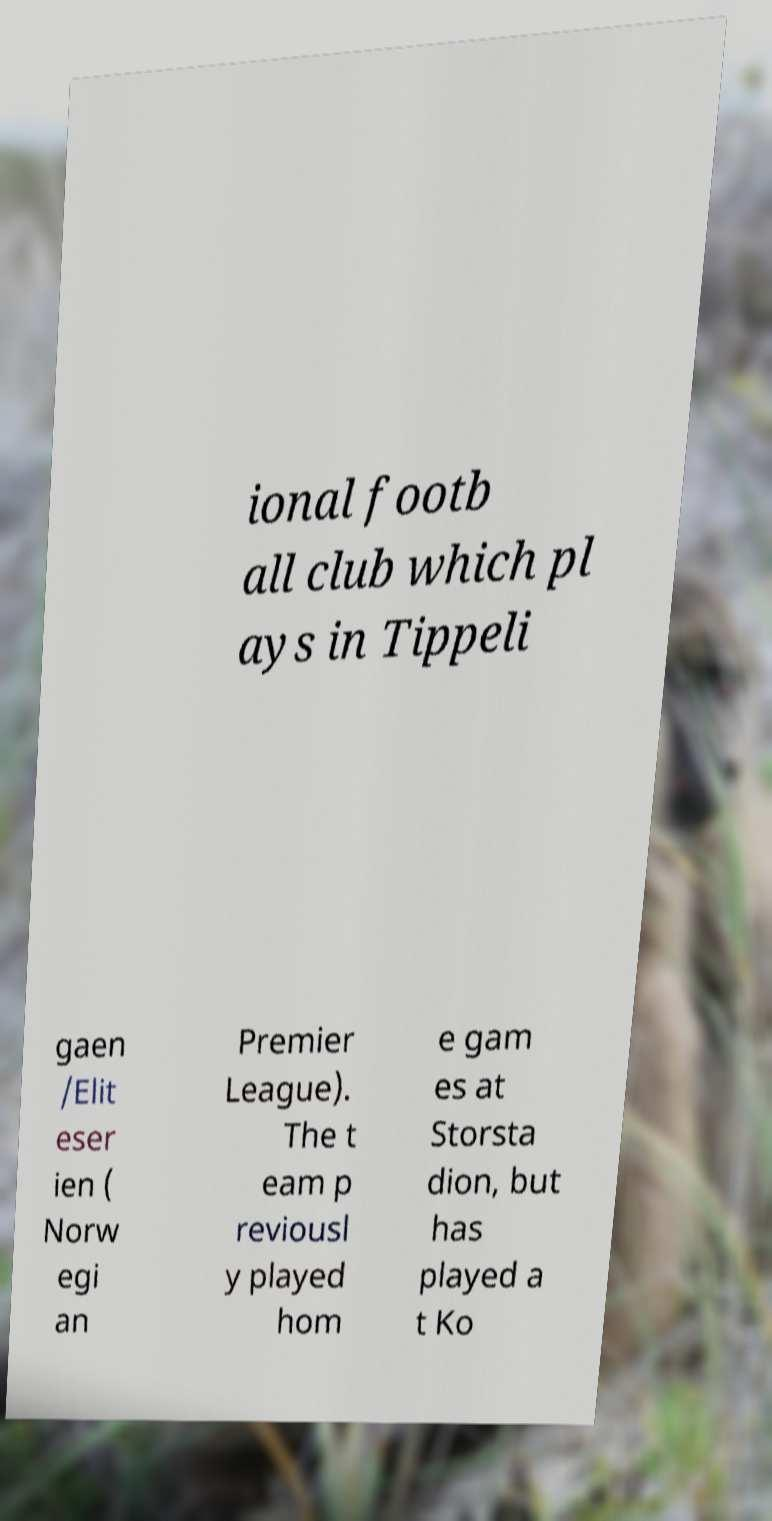Could you assist in decoding the text presented in this image and type it out clearly? ional footb all club which pl ays in Tippeli gaen /Elit eser ien ( Norw egi an Premier League). The t eam p reviousl y played hom e gam es at Storsta dion, but has played a t Ko 